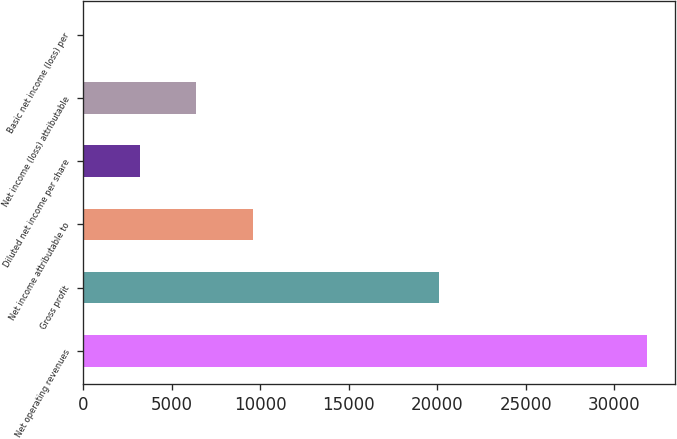<chart> <loc_0><loc_0><loc_500><loc_500><bar_chart><fcel>Net operating revenues<fcel>Gross profit<fcel>Net income attributable to<fcel>Diluted net income per share<fcel>Net income (loss) attributable<fcel>Basic net income (loss) per<nl><fcel>31856<fcel>20086<fcel>9557<fcel>3185.86<fcel>6371.43<fcel>0.29<nl></chart> 